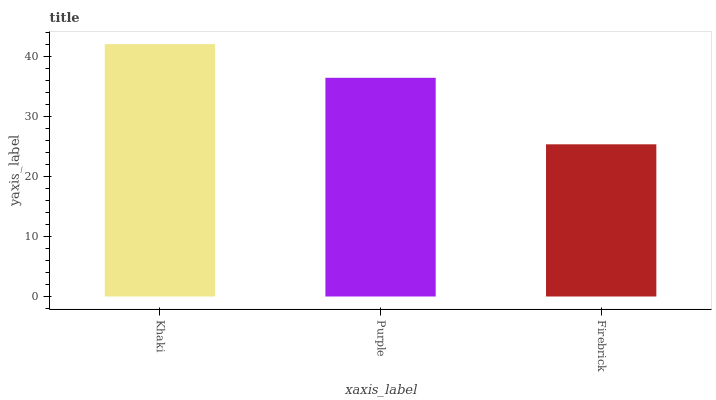Is Firebrick the minimum?
Answer yes or no. Yes. Is Khaki the maximum?
Answer yes or no. Yes. Is Purple the minimum?
Answer yes or no. No. Is Purple the maximum?
Answer yes or no. No. Is Khaki greater than Purple?
Answer yes or no. Yes. Is Purple less than Khaki?
Answer yes or no. Yes. Is Purple greater than Khaki?
Answer yes or no. No. Is Khaki less than Purple?
Answer yes or no. No. Is Purple the high median?
Answer yes or no. Yes. Is Purple the low median?
Answer yes or no. Yes. Is Firebrick the high median?
Answer yes or no. No. Is Firebrick the low median?
Answer yes or no. No. 